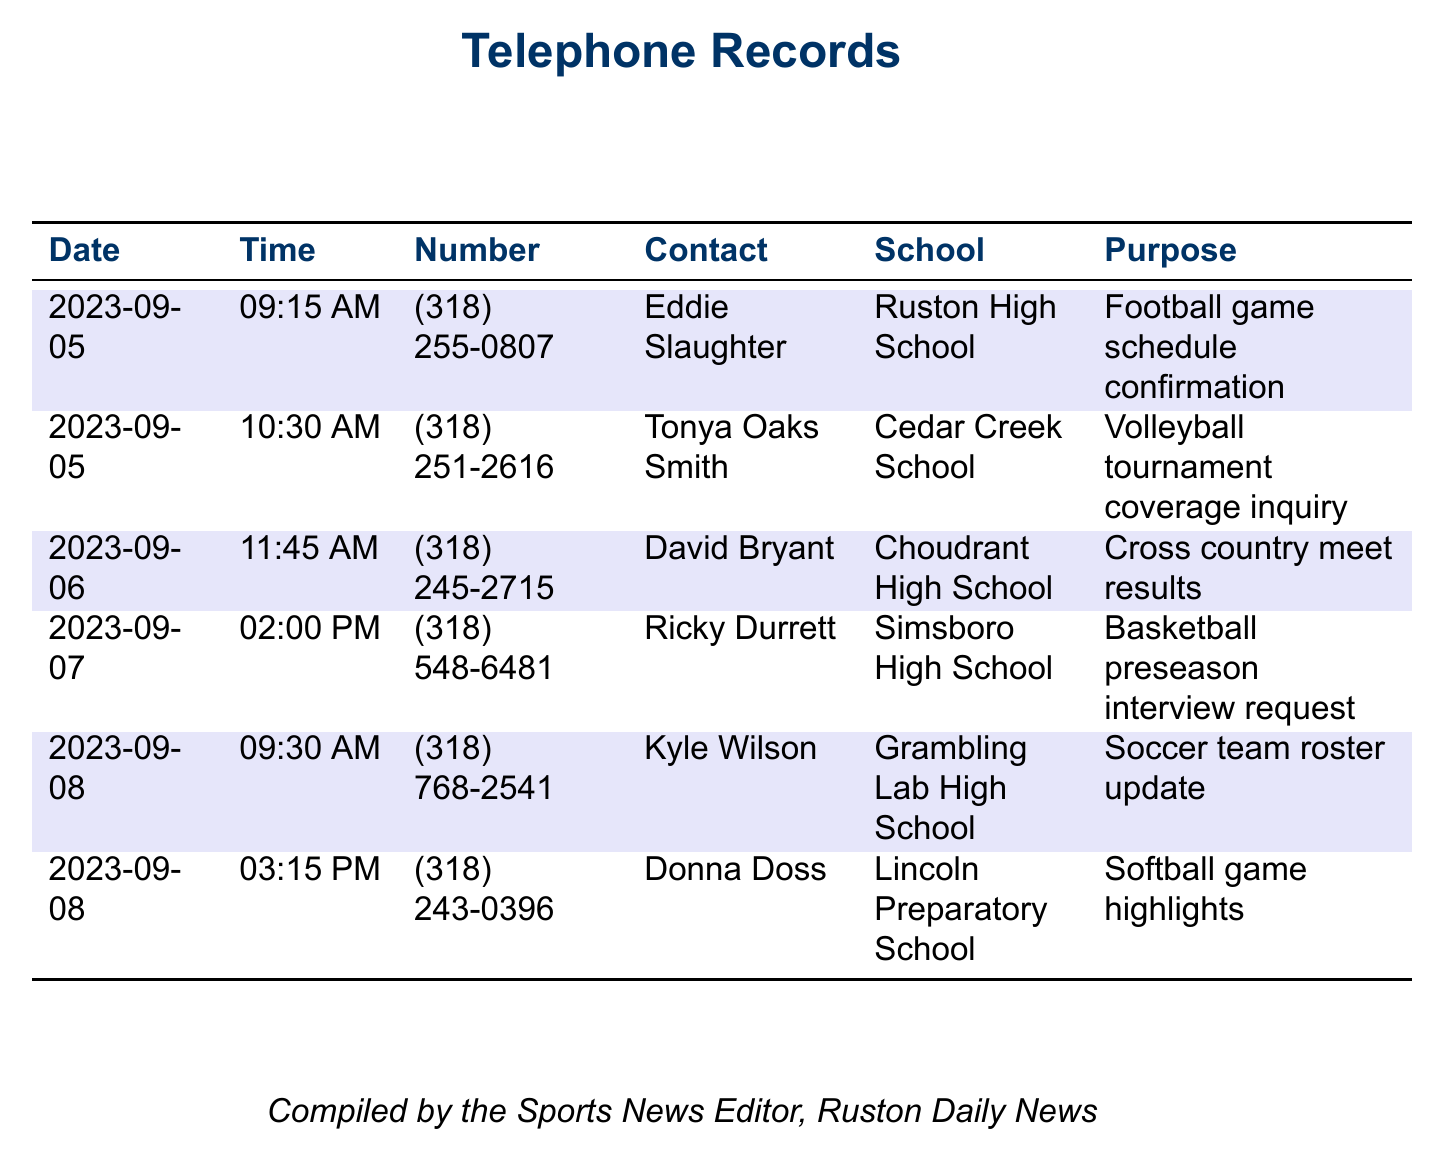What date did Eddie Slaughter’s call occur? Eddie Slaughter’s call took place on September 5, 2023, as listed in the telephone records.
Answer: 2023-09-05 What school is associated with the call to Tonya Oaks Smith? The document states that Tonya Oaks Smith is associated with Cedar Creek School.
Answer: Cedar Creek School What was the purpose of the call made to Ricky Durrett? The purpose of the call to Ricky Durrett was to request a preseason interview regarding basketball.
Answer: Basketball preseason interview request How many calls were recorded on September 8, 2023? There are two calls recorded on September 8, 2023, as shown in the table.
Answer: 2 Which director is contacted for soccer team updates? Kyle Wilson is the contact for soccer team roster updates in the records.
Answer: Kyle Wilson What time was the call to David Bryant? The call to David Bryant was made at 11:45 AM, as specified in the records.
Answer: 11:45 AM What is the phone number for Lincoln Preparatory School's contact? The phone number listed for Lincoln Preparatory School's contact, Donna Doss, is (318) 243-0396.
Answer: (318) 243-0396 Which school’s athletic director was contacted about cross country meet results? David Bryant, contacted about cross country meet results, is associated with Choudrant High School.
Answer: Choudrant High School What event type was inquired about in the call to Tonya Oaks Smith? The inquiry made in the call to Tonya Oaks Smith was about a volleyball tournament.
Answer: Volleyball tournament coverage inquiry 